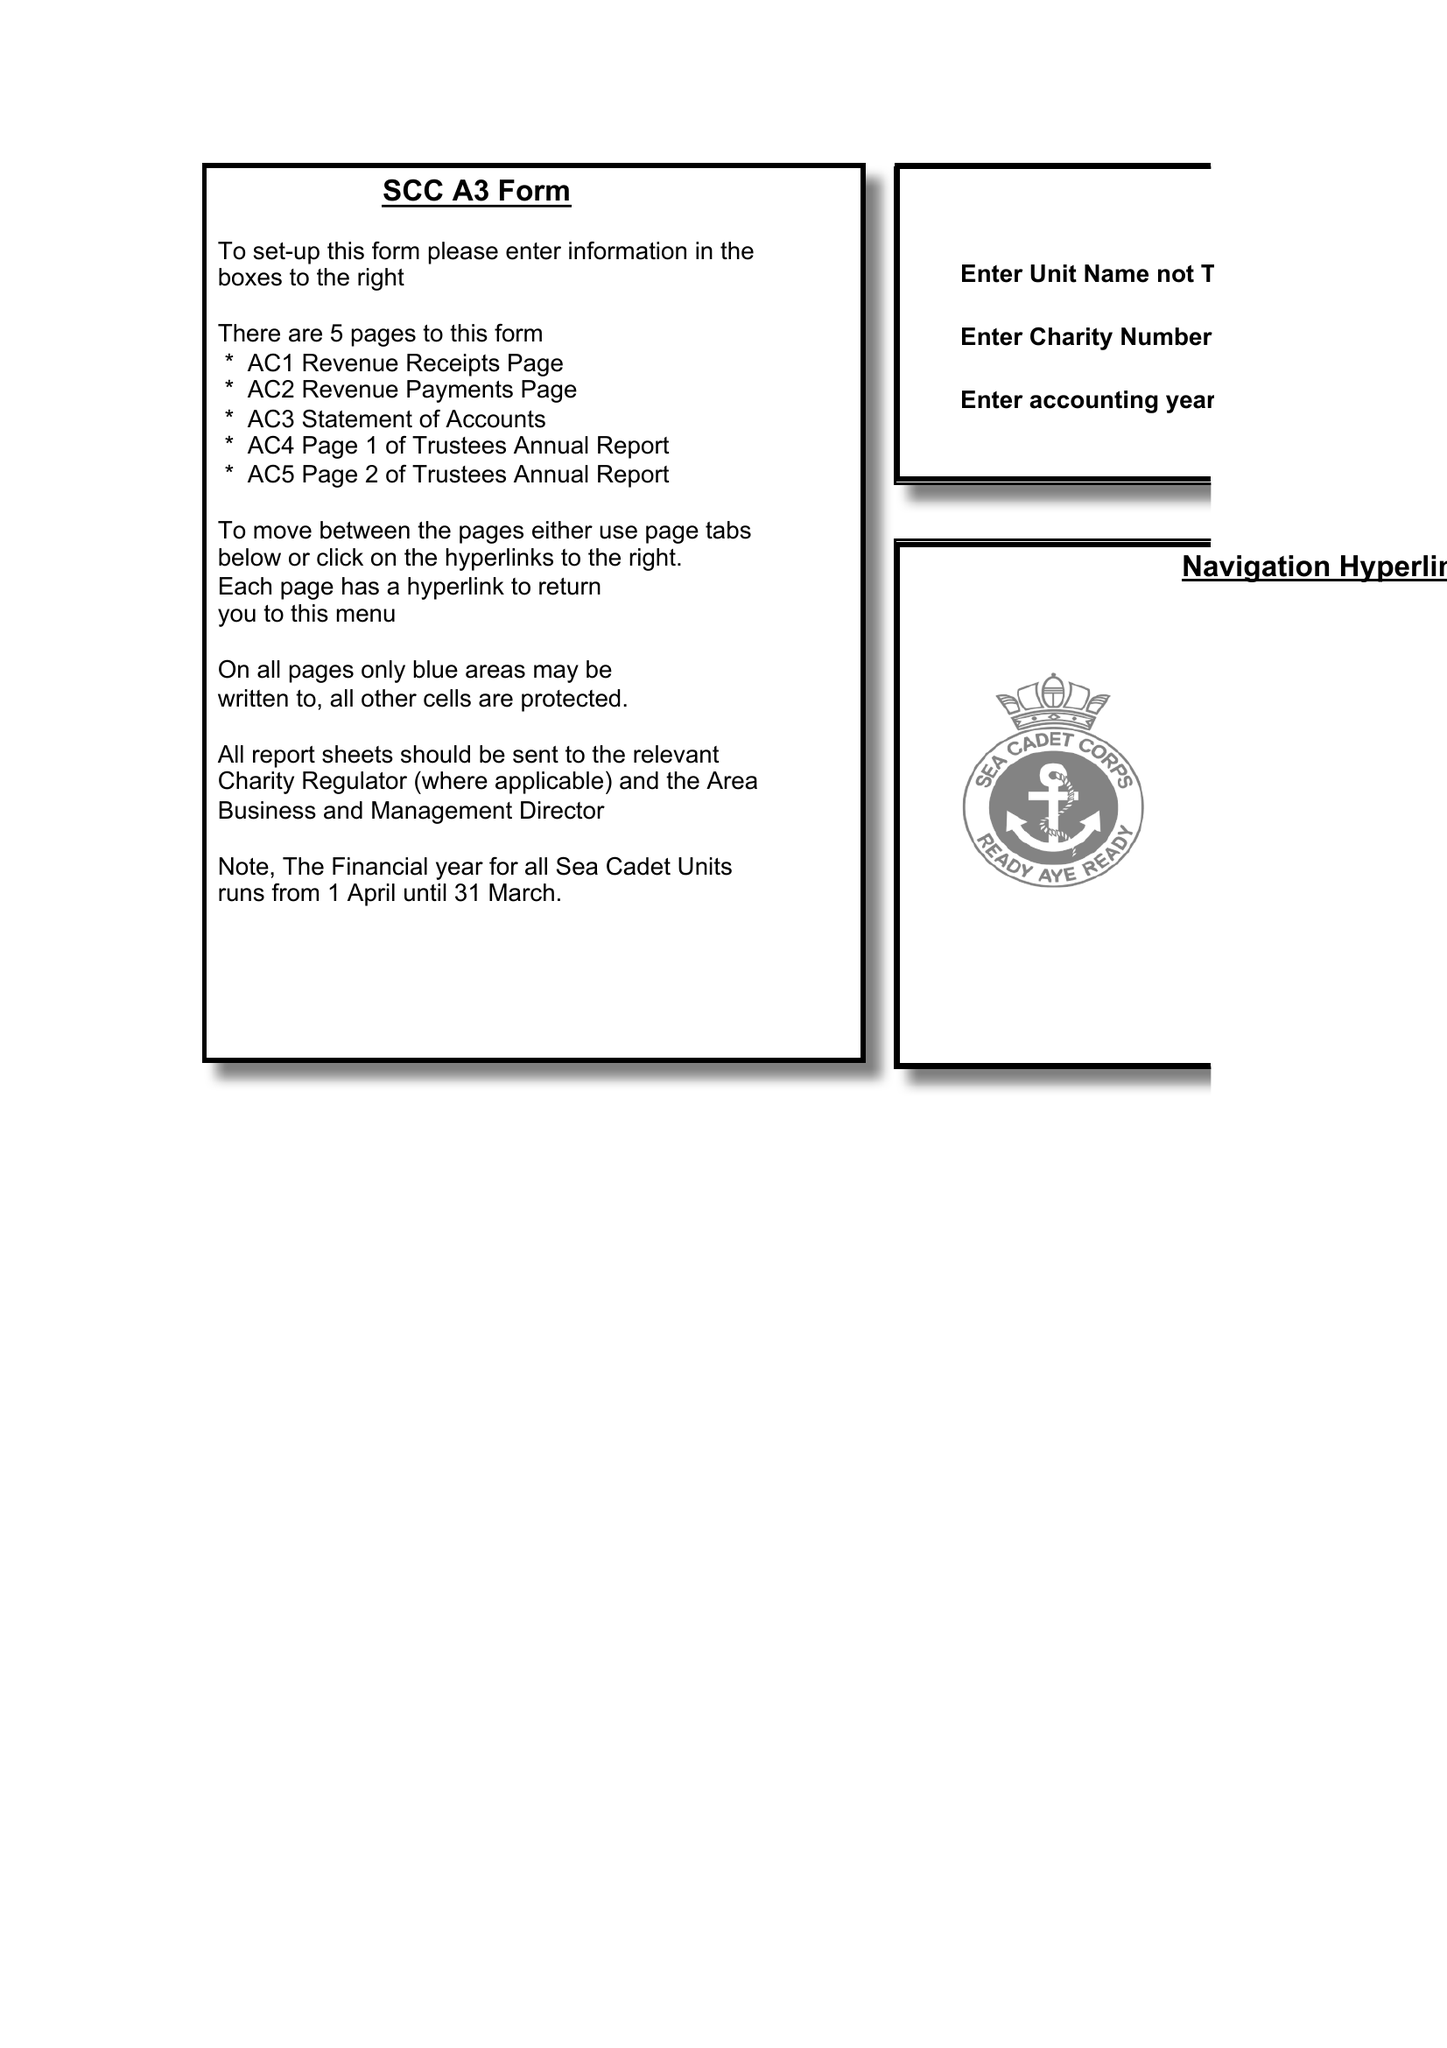What is the value for the address__post_town?
Answer the question using a single word or phrase. PORTHCAWL 